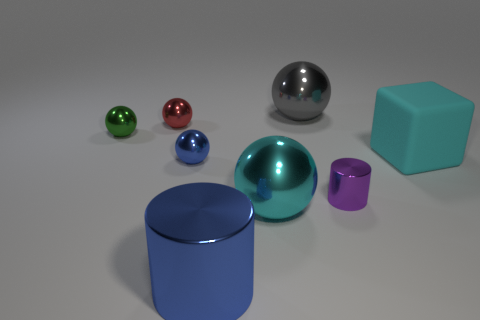Does the cyan object to the left of the big cube have the same size as the blue metallic thing that is to the left of the blue metal cylinder?
Offer a terse response. No. Are there any small red metallic balls that are on the right side of the tiny metal sphere that is behind the green thing?
Offer a terse response. No. How many big things are in front of the tiny purple metal cylinder?
Keep it short and to the point. 2. How many other things are the same color as the big block?
Your answer should be compact. 1. Is the number of cyan cubes that are in front of the big blue shiny thing less than the number of big gray metal objects that are on the right side of the cyan ball?
Provide a short and direct response. Yes. What number of objects are cyan rubber blocks in front of the gray metal sphere or large green metal objects?
Offer a terse response. 1. Does the cyan cube have the same size as the blue metallic object behind the blue metal cylinder?
Ensure brevity in your answer.  No. What size is the other object that is the same shape as the big blue shiny object?
Ensure brevity in your answer.  Small. What number of tiny blue metal spheres are to the right of the sphere that is behind the tiny shiny thing behind the green metallic sphere?
Keep it short and to the point. 0. What number of cubes are big metal objects or tiny green shiny things?
Give a very brief answer. 0. 